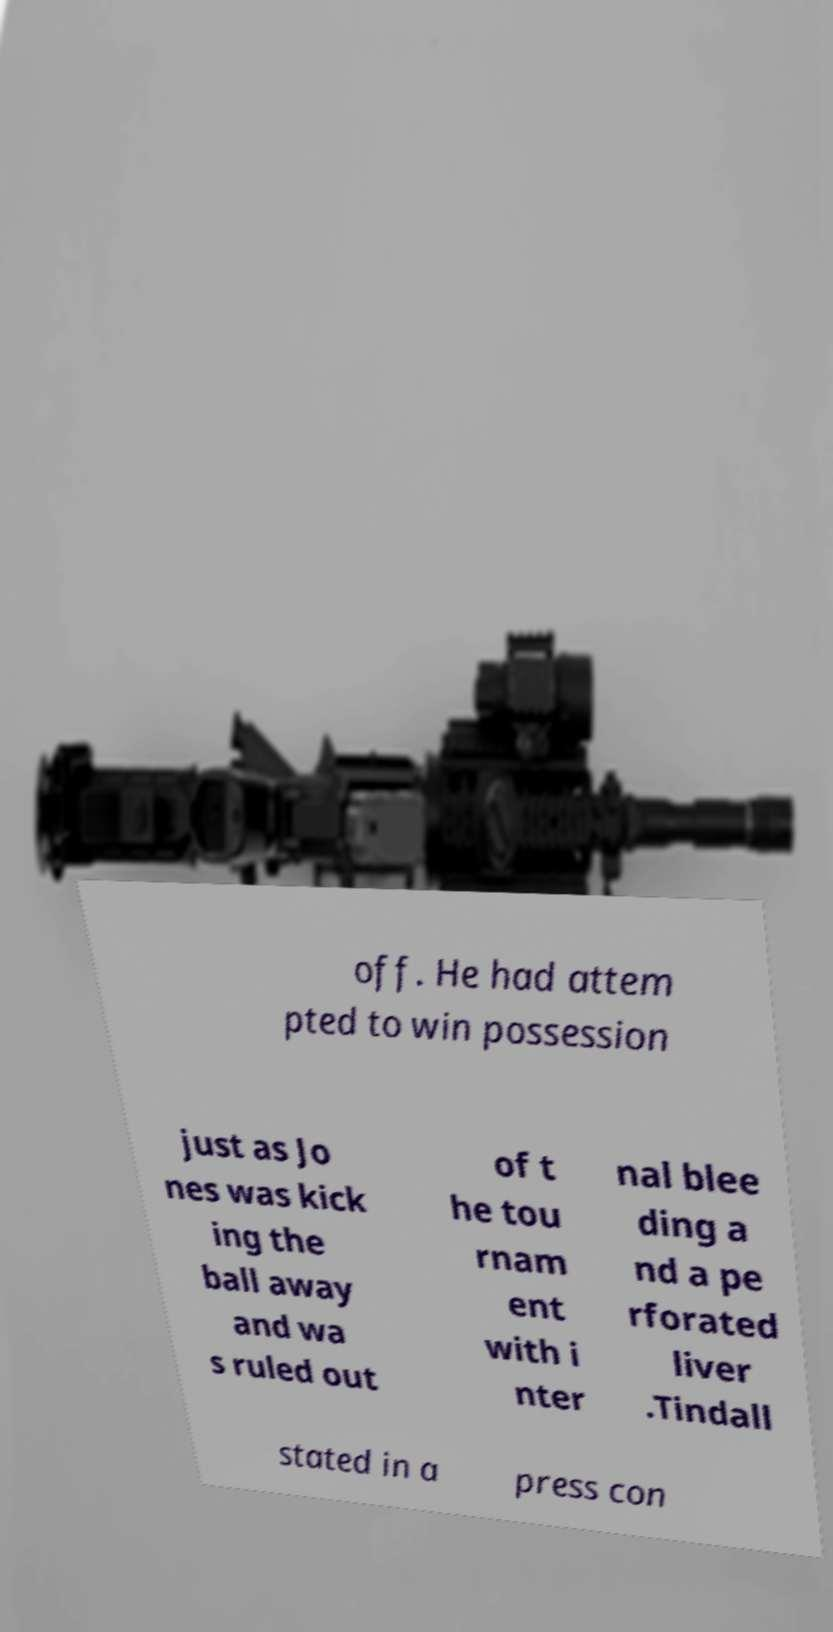I need the written content from this picture converted into text. Can you do that? off. He had attem pted to win possession just as Jo nes was kick ing the ball away and wa s ruled out of t he tou rnam ent with i nter nal blee ding a nd a pe rforated liver .Tindall stated in a press con 